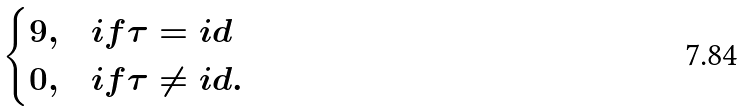<formula> <loc_0><loc_0><loc_500><loc_500>\begin{cases} 9 , & i f \tau = i d \\ 0 , & i f \tau \neq i d . \end{cases}</formula> 